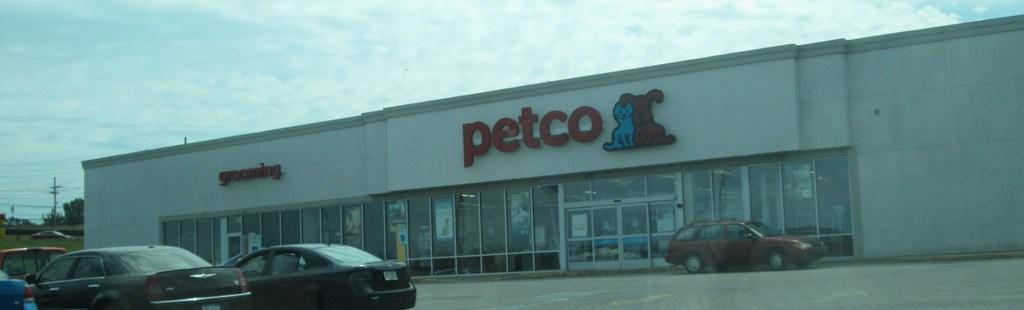Could you give a brief overview of what you see in this image? In this image I can see few vehicles on the road. Back Side I can see a building,poles,wires,trees and glass windows. The sky is in white and blue color. 